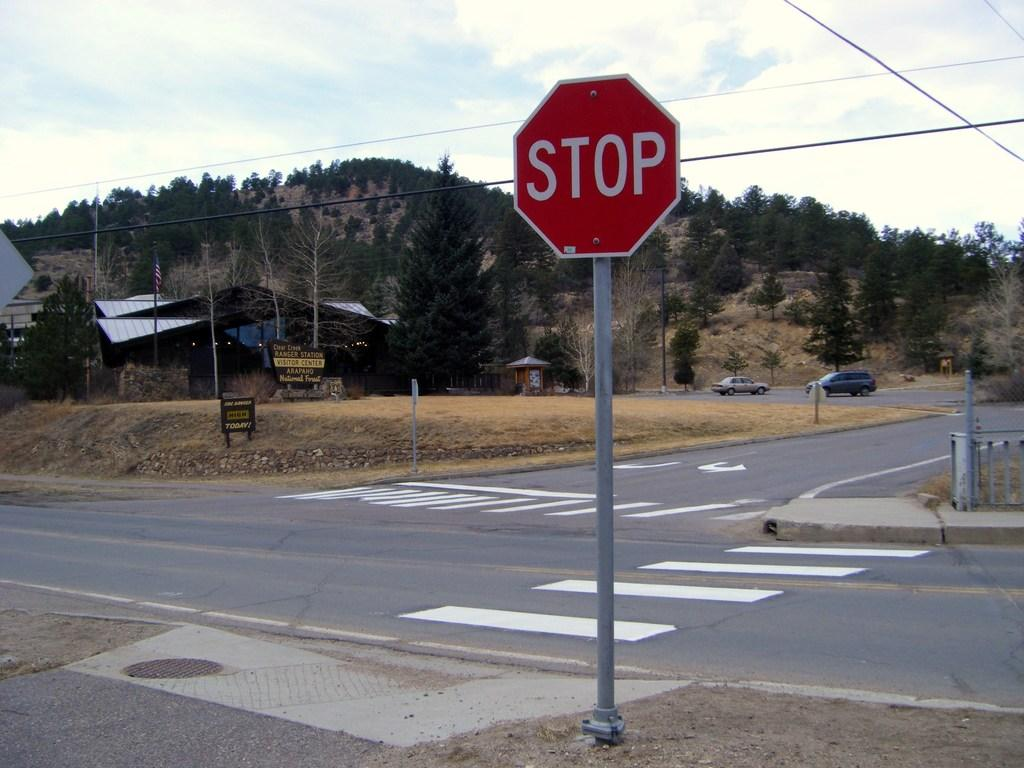<image>
Describe the image concisely. A stop sign is posted at the corner of an empty intersection. 